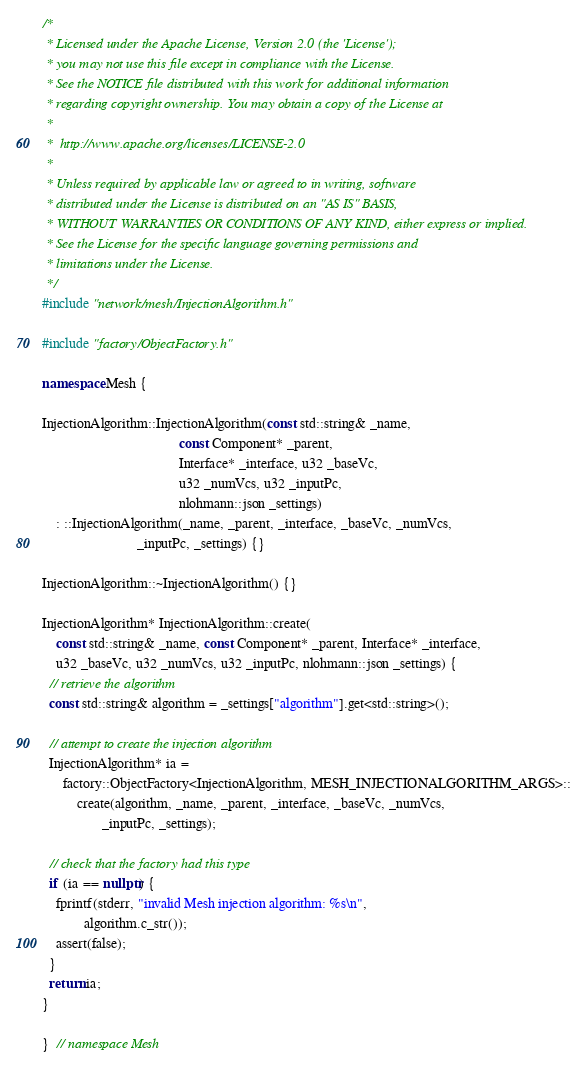Convert code to text. <code><loc_0><loc_0><loc_500><loc_500><_C++_>/*
 * Licensed under the Apache License, Version 2.0 (the 'License');
 * you may not use this file except in compliance with the License.
 * See the NOTICE file distributed with this work for additional information
 * regarding copyright ownership. You may obtain a copy of the License at
 *
 *  http://www.apache.org/licenses/LICENSE-2.0
 *
 * Unless required by applicable law or agreed to in writing, software
 * distributed under the License is distributed on an "AS IS" BASIS,
 * WITHOUT WARRANTIES OR CONDITIONS OF ANY KIND, either express or implied.
 * See the License for the specific language governing permissions and
 * limitations under the License.
 */
#include "network/mesh/InjectionAlgorithm.h"

#include "factory/ObjectFactory.h"

namespace Mesh {

InjectionAlgorithm::InjectionAlgorithm(const std::string& _name,
                                       const Component* _parent,
                                       Interface* _interface, u32 _baseVc,
                                       u32 _numVcs, u32 _inputPc,
                                       nlohmann::json _settings)
    : ::InjectionAlgorithm(_name, _parent, _interface, _baseVc, _numVcs,
                           _inputPc, _settings) {}

InjectionAlgorithm::~InjectionAlgorithm() {}

InjectionAlgorithm* InjectionAlgorithm::create(
    const std::string& _name, const Component* _parent, Interface* _interface,
    u32 _baseVc, u32 _numVcs, u32 _inputPc, nlohmann::json _settings) {
  // retrieve the algorithm
  const std::string& algorithm = _settings["algorithm"].get<std::string>();

  // attempt to create the injection algorithm
  InjectionAlgorithm* ia =
      factory::ObjectFactory<InjectionAlgorithm, MESH_INJECTIONALGORITHM_ARGS>::
          create(algorithm, _name, _parent, _interface, _baseVc, _numVcs,
                 _inputPc, _settings);

  // check that the factory had this type
  if (ia == nullptr) {
    fprintf(stderr, "invalid Mesh injection algorithm: %s\n",
            algorithm.c_str());
    assert(false);
  }
  return ia;
}

}  // namespace Mesh
</code> 